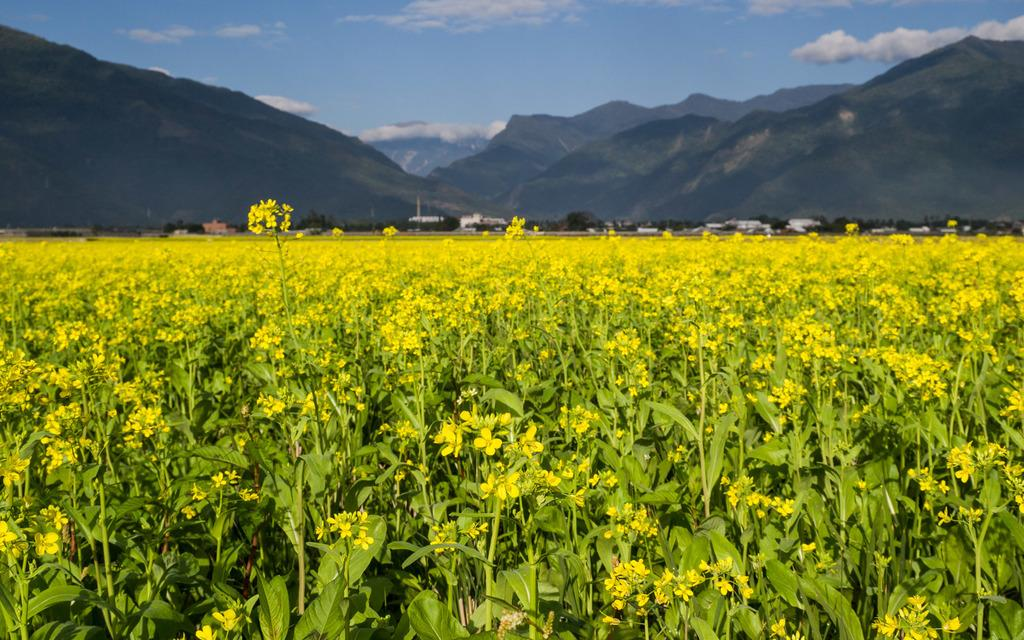What type of plants are in the image? There are flower plants in the image. What color are the flowers? The flowers are yellow. What can be seen in the background of the image? There are mountains, buildings, trees, and the sky visible in the background of the image. What activity is causing the flowers to feel angry in the image? There is no indication in the image that the flowers are feeling any emotions, including anger. 